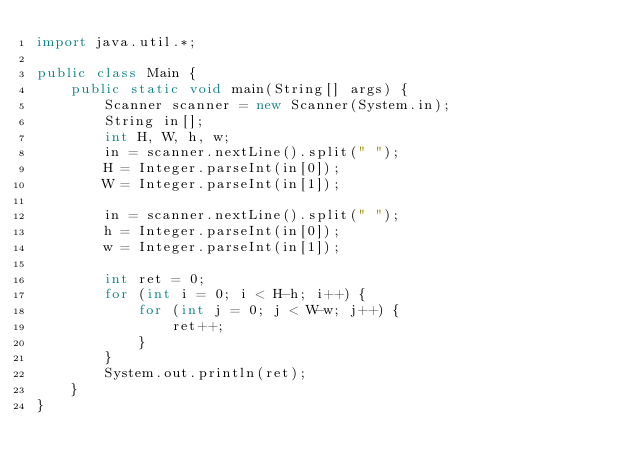Convert code to text. <code><loc_0><loc_0><loc_500><loc_500><_Java_>import java.util.*;

public class Main {
    public static void main(String[] args) {
        Scanner scanner = new Scanner(System.in);
        String in[];
        int H, W, h, w;
        in = scanner.nextLine().split(" ");
        H = Integer.parseInt(in[0]);
        W = Integer.parseInt(in[1]);

        in = scanner.nextLine().split(" ");
        h = Integer.parseInt(in[0]);
        w = Integer.parseInt(in[1]);

        int ret = 0;
        for (int i = 0; i < H-h; i++) {
            for (int j = 0; j < W-w; j++) {
                ret++;
            }
        }
        System.out.println(ret);
    }
}</code> 